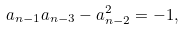Convert formula to latex. <formula><loc_0><loc_0><loc_500><loc_500>a _ { n - 1 } a _ { n - 3 } - a _ { n - 2 } ^ { 2 } = - 1 ,</formula> 